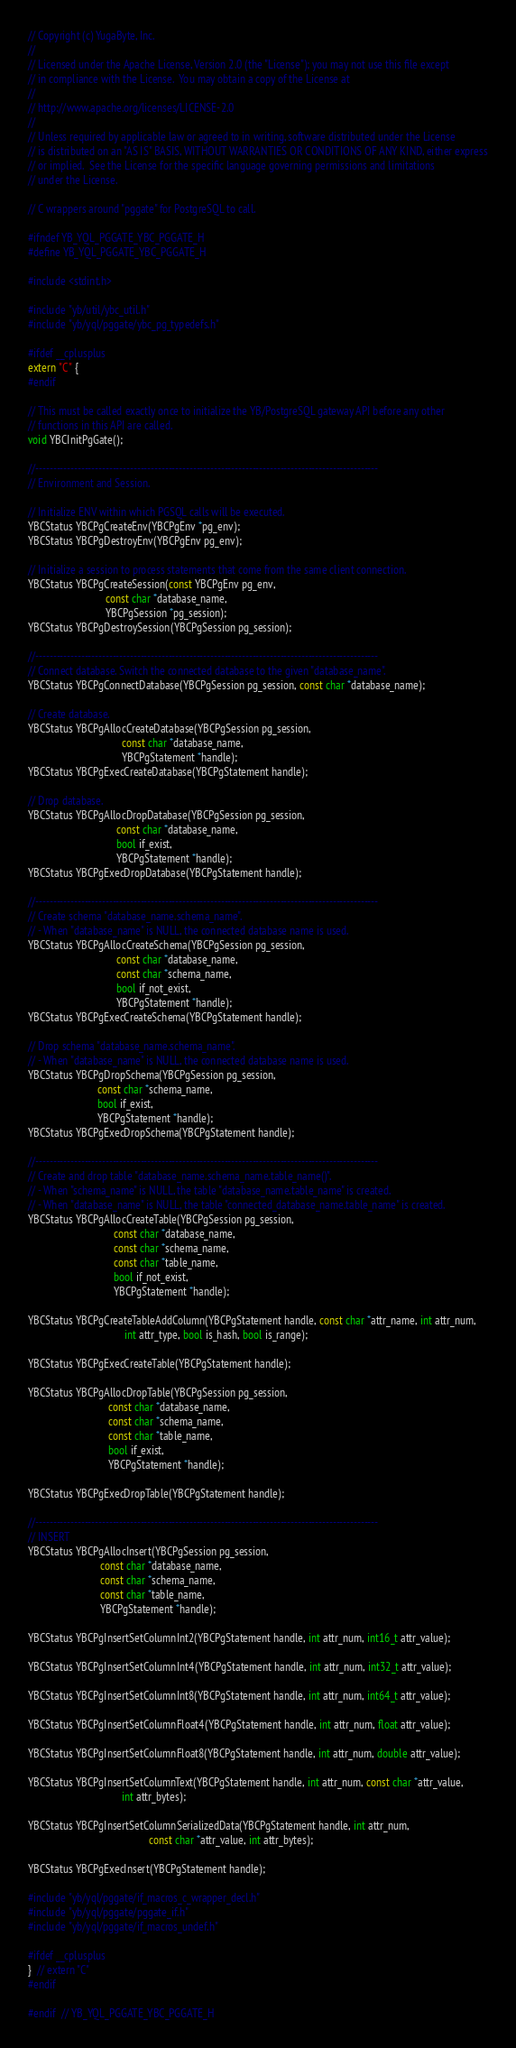Convert code to text. <code><loc_0><loc_0><loc_500><loc_500><_C_>// Copyright (c) YugaByte, Inc.
//
// Licensed under the Apache License, Version 2.0 (the "License"); you may not use this file except
// in compliance with the License.  You may obtain a copy of the License at
//
// http://www.apache.org/licenses/LICENSE-2.0
//
// Unless required by applicable law or agreed to in writing, software distributed under the License
// is distributed on an "AS IS" BASIS, WITHOUT WARRANTIES OR CONDITIONS OF ANY KIND, either express
// or implied.  See the License for the specific language governing permissions and limitations
// under the License.

// C wrappers around "pggate" for PostgreSQL to call.

#ifndef YB_YQL_PGGATE_YBC_PGGATE_H
#define YB_YQL_PGGATE_YBC_PGGATE_H

#include <stdint.h>

#include "yb/util/ybc_util.h"
#include "yb/yql/pggate/ybc_pg_typedefs.h"

#ifdef __cplusplus
extern "C" {
#endif

// This must be called exactly once to initialize the YB/PostgreSQL gateway API before any other
// functions in this API are called.
void YBCInitPgGate();

//--------------------------------------------------------------------------------------------------
// Environment and Session.

// Initialize ENV within which PGSQL calls will be executed.
YBCStatus YBCPgCreateEnv(YBCPgEnv *pg_env);
YBCStatus YBCPgDestroyEnv(YBCPgEnv pg_env);

// Initialize a session to process statements that come from the same client connection.
YBCStatus YBCPgCreateSession(const YBCPgEnv pg_env,
                             const char *database_name,
                             YBCPgSession *pg_session);
YBCStatus YBCPgDestroySession(YBCPgSession pg_session);

//--------------------------------------------------------------------------------------------------
// Connect database. Switch the connected database to the given "database_name".
YBCStatus YBCPgConnectDatabase(YBCPgSession pg_session, const char *database_name);

// Create database.
YBCStatus YBCPgAllocCreateDatabase(YBCPgSession pg_session,
                                   const char *database_name,
                                   YBCPgStatement *handle);
YBCStatus YBCPgExecCreateDatabase(YBCPgStatement handle);

// Drop database.
YBCStatus YBCPgAllocDropDatabase(YBCPgSession pg_session,
                                 const char *database_name,
                                 bool if_exist,
                                 YBCPgStatement *handle);
YBCStatus YBCPgExecDropDatabase(YBCPgStatement handle);

//--------------------------------------------------------------------------------------------------
// Create schema "database_name.schema_name".
// - When "database_name" is NULL, the connected database name is used.
YBCStatus YBCPgAllocCreateSchema(YBCPgSession pg_session,
                                 const char *database_name,
                                 const char *schema_name,
                                 bool if_not_exist,
                                 YBCPgStatement *handle);
YBCStatus YBCPgExecCreateSchema(YBCPgStatement handle);

// Drop schema "database_name.schema_name".
// - When "database_name" is NULL, the connected database name is used.
YBCStatus YBCPgDropSchema(YBCPgSession pg_session,
                          const char *schema_name,
                          bool if_exist,
                          YBCPgStatement *handle);
YBCStatus YBCPgExecDropSchema(YBCPgStatement handle);

//--------------------------------------------------------------------------------------------------
// Create and drop table "database_name.schema_name.table_name()".
// - When "schema_name" is NULL, the table "database_name.table_name" is created.
// - When "database_name" is NULL, the table "connected_database_name.table_name" is created.
YBCStatus YBCPgAllocCreateTable(YBCPgSession pg_session,
                                const char *database_name,
                                const char *schema_name,
                                const char *table_name,
                                bool if_not_exist,
                                YBCPgStatement *handle);

YBCStatus YBCPgCreateTableAddColumn(YBCPgStatement handle, const char *attr_name, int attr_num,
                                    int attr_type, bool is_hash, bool is_range);

YBCStatus YBCPgExecCreateTable(YBCPgStatement handle);

YBCStatus YBCPgAllocDropTable(YBCPgSession pg_session,
                              const char *database_name,
                              const char *schema_name,
                              const char *table_name,
                              bool if_exist,
                              YBCPgStatement *handle);

YBCStatus YBCPgExecDropTable(YBCPgStatement handle);

//--------------------------------------------------------------------------------------------------
// INSERT
YBCStatus YBCPgAllocInsert(YBCPgSession pg_session,
                           const char *database_name,
                           const char *schema_name,
                           const char *table_name,
                           YBCPgStatement *handle);

YBCStatus YBCPgInsertSetColumnInt2(YBCPgStatement handle, int attr_num, int16_t attr_value);

YBCStatus YBCPgInsertSetColumnInt4(YBCPgStatement handle, int attr_num, int32_t attr_value);

YBCStatus YBCPgInsertSetColumnInt8(YBCPgStatement handle, int attr_num, int64_t attr_value);

YBCStatus YBCPgInsertSetColumnFloat4(YBCPgStatement handle, int attr_num, float attr_value);

YBCStatus YBCPgInsertSetColumnFloat8(YBCPgStatement handle, int attr_num, double attr_value);

YBCStatus YBCPgInsertSetColumnText(YBCPgStatement handle, int attr_num, const char *attr_value,
                                   int attr_bytes);

YBCStatus YBCPgInsertSetColumnSerializedData(YBCPgStatement handle, int attr_num,
                                             const char *attr_value, int attr_bytes);

YBCStatus YBCPgExecInsert(YBCPgStatement handle);

#include "yb/yql/pggate/if_macros_c_wrapper_decl.h"
#include "yb/yql/pggate/pggate_if.h"
#include "yb/yql/pggate/if_macros_undef.h"

#ifdef __cplusplus
}  // extern "C"
#endif

#endif  // YB_YQL_PGGATE_YBC_PGGATE_H
</code> 